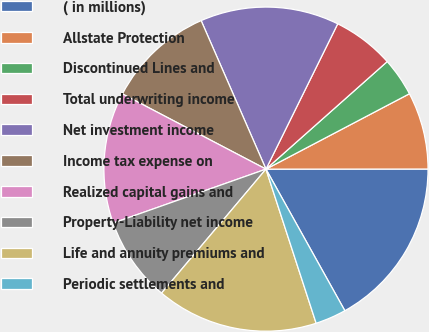Convert chart. <chart><loc_0><loc_0><loc_500><loc_500><pie_chart><fcel>( in millions)<fcel>Allstate Protection<fcel>Discontinued Lines and<fcel>Total underwriting income<fcel>Net investment income<fcel>Income tax expense on<fcel>Realized capital gains and<fcel>Property-Liability net income<fcel>Life and annuity premiums and<fcel>Periodic settlements and<nl><fcel>16.92%<fcel>7.69%<fcel>3.85%<fcel>6.15%<fcel>13.85%<fcel>10.77%<fcel>13.08%<fcel>8.46%<fcel>16.15%<fcel>3.08%<nl></chart> 